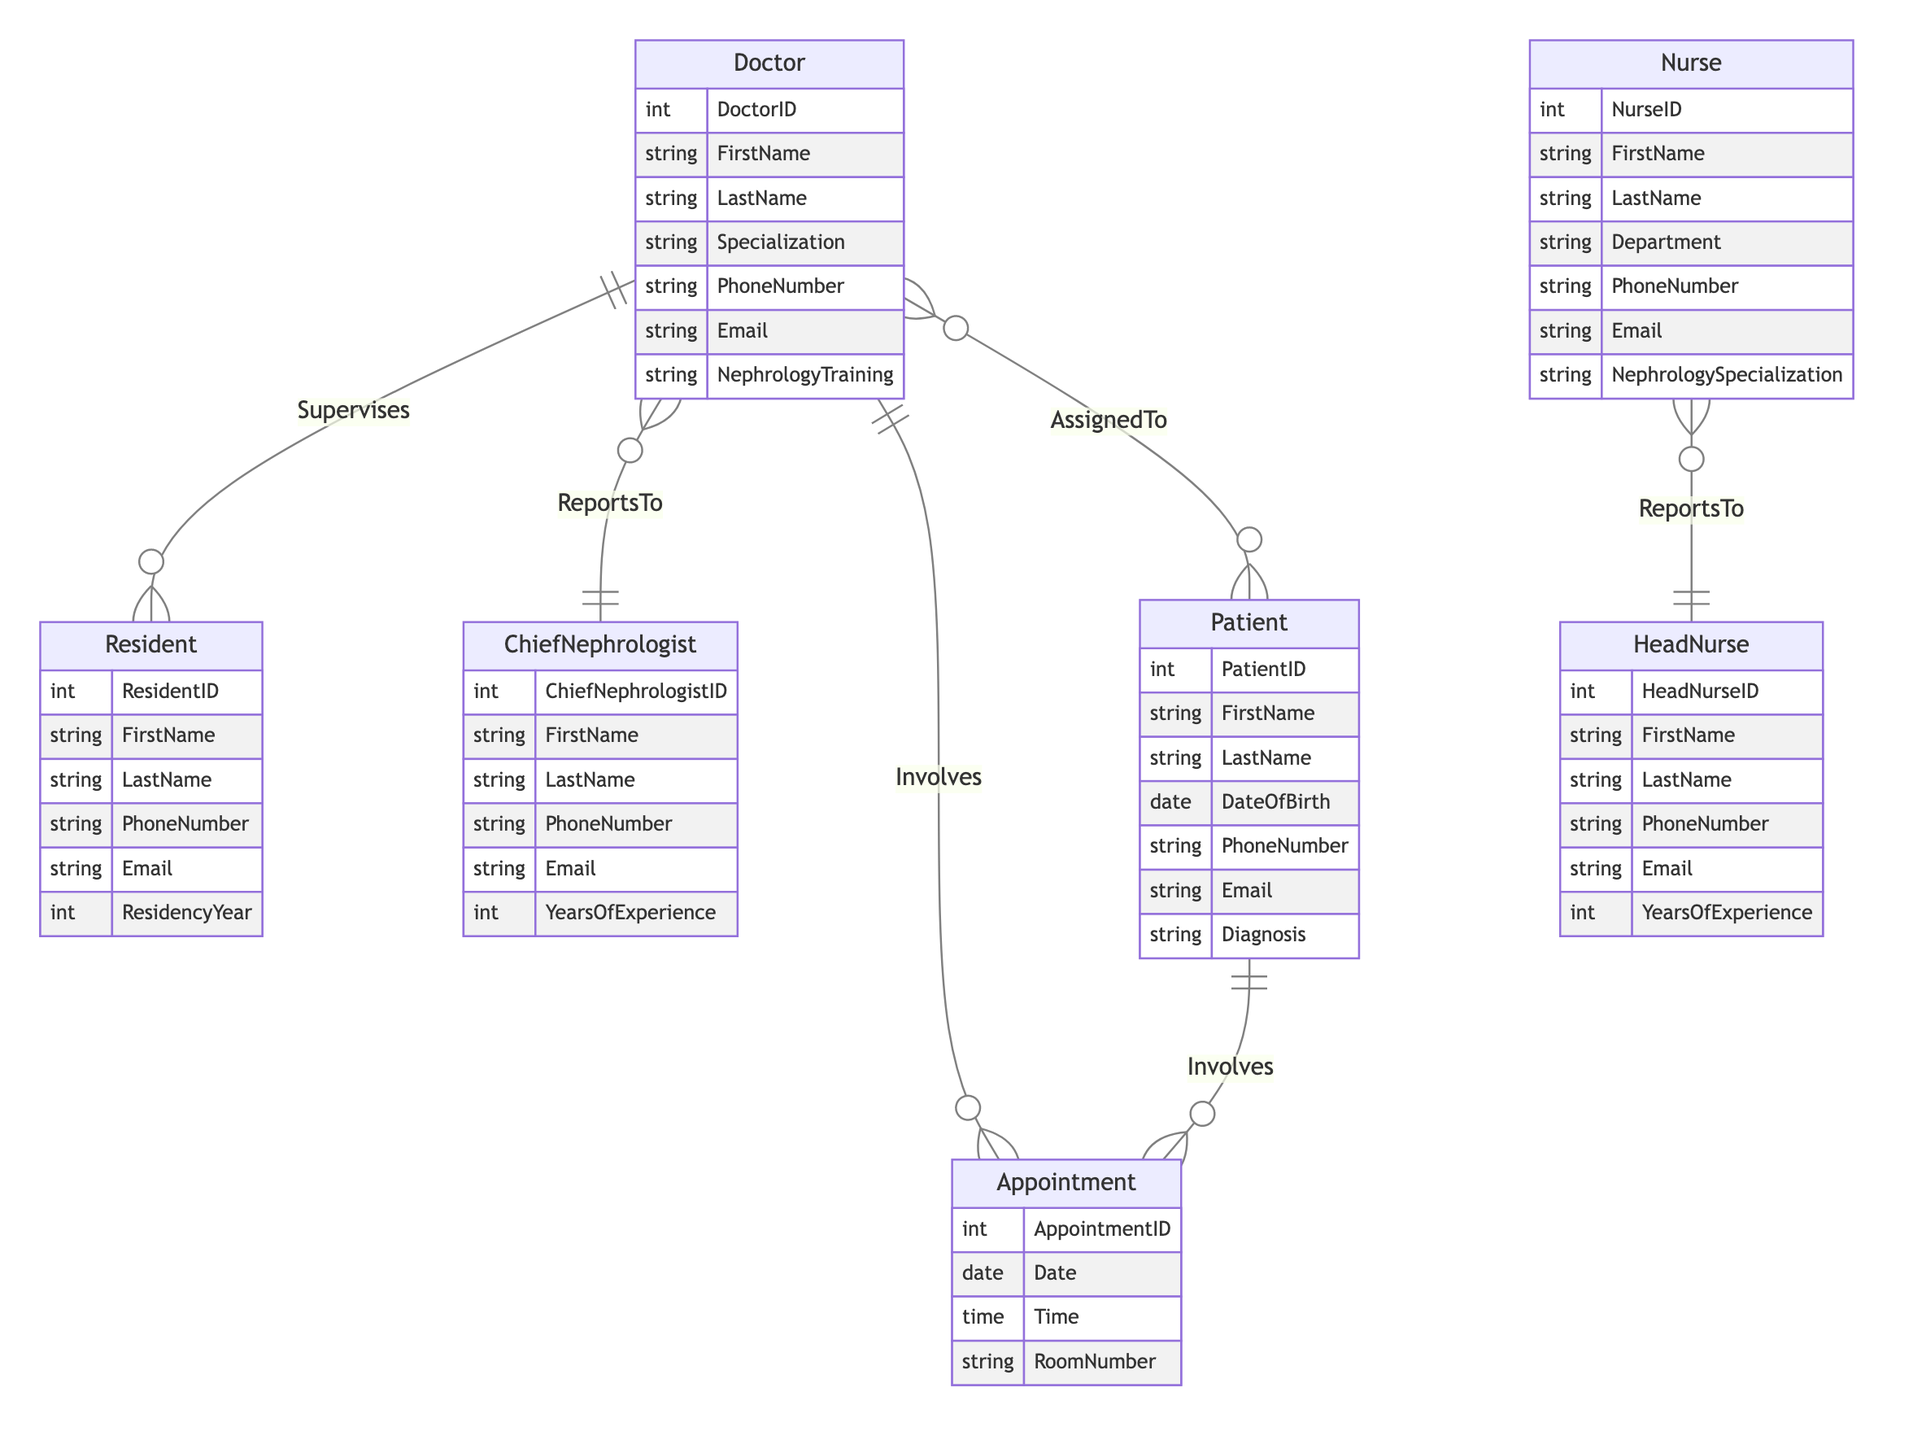What is the primary relationship between Doctor and Resident? The diagram indicates that a Doctor supervises many Residents, which establishes a one-to-many relationship where each Doctor can oversee several Residents.
Answer: Supervises How many entities are in the diagram? The diagram includes a total of six entities: Doctor, Nurse, Patient, Appointment, Chief Nephrologist, Resident, and Head Nurse. Therefore, the count of unique entities is seven.
Answer: Seven Who reports to the Chief Nephrologist? According to the relationships depicted, all Doctors in the Nephrology Department report to the Chief Nephrologist, establishing a direct reporting line.
Answer: Doctors What is the nature of the relationship between Patient and Appointment? The relationship between Patient and Appointment is many-to-many. This means that a single Patient can be involved in multiple Appointments, and an Appointment can have multiple involved Patients.
Answer: Many-to-Many How many doctors can a resident be supervised by? Each Resident can be supervised by one Doctor, as indicated by the many-to-one relationship between Resident and Doctor.
Answer: One What indicates the level of experience of the Chief Nephrologist? The Chief Nephrologist's level of experience is represented by the attribute "YearsOfExperience," which quantifies their time in the nephrology field, thus indicating their experience level.
Answer: YearsOfExperience Which entity reports to the Head Nurse? The Nurse entity reports to the Head Nurse, as specified by the many-to-one relationship in the diagram, indicating that multiple Nurses can have the same Head Nurse overseeing them.
Answer: Nurses What is the relationship type between Doctor and Patient? The relationship type between Doctor and Patient is many-to-many, meaning several Doctors can be assigned to multiple Patients and vice versa, illustrating collaborative care in the nephrology department.
Answer: Many-to-Many 